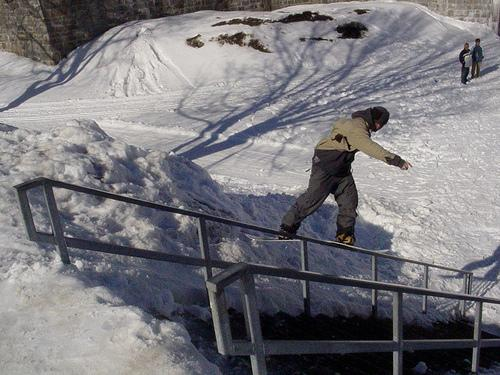What move is the snowboarder doing? Please explain your reasoning. grind. He is going down the rail. 